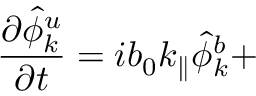<formula> <loc_0><loc_0><loc_500><loc_500>{ \frac { \partial \hat { \phi } _ { k } ^ { u } } { \partial t } } = i b _ { 0 } k _ { \| } \hat { \phi } _ { k } ^ { b } +</formula> 